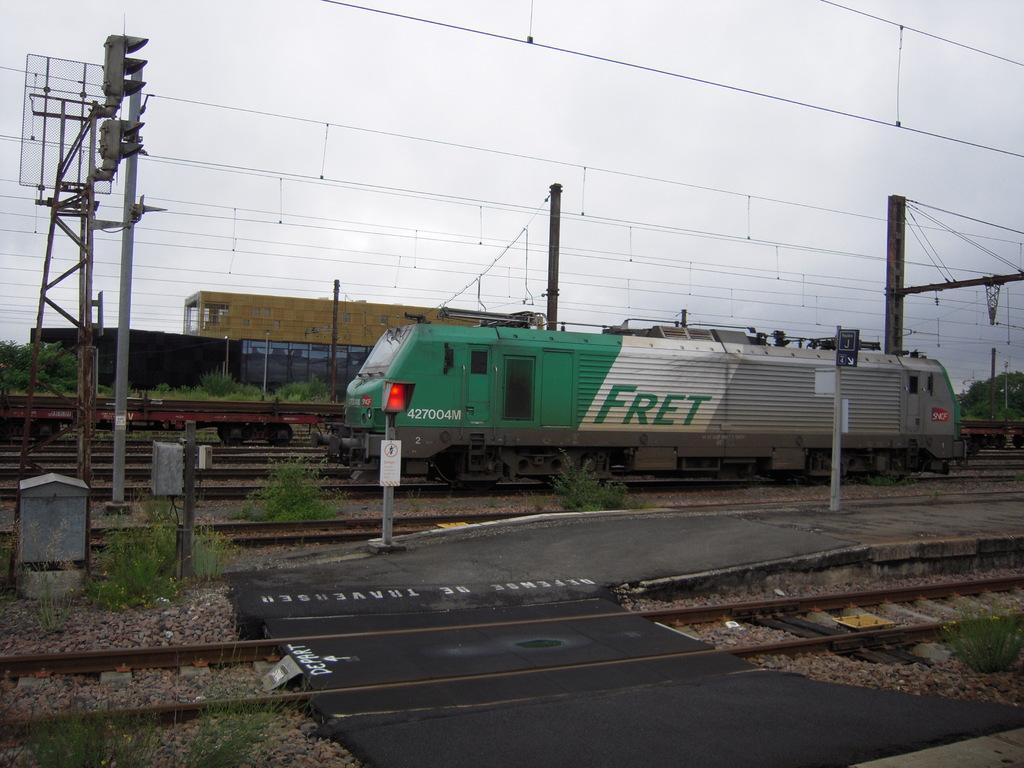<image>
Offer a succinct explanation of the picture presented. the word fret is on the side of a train 